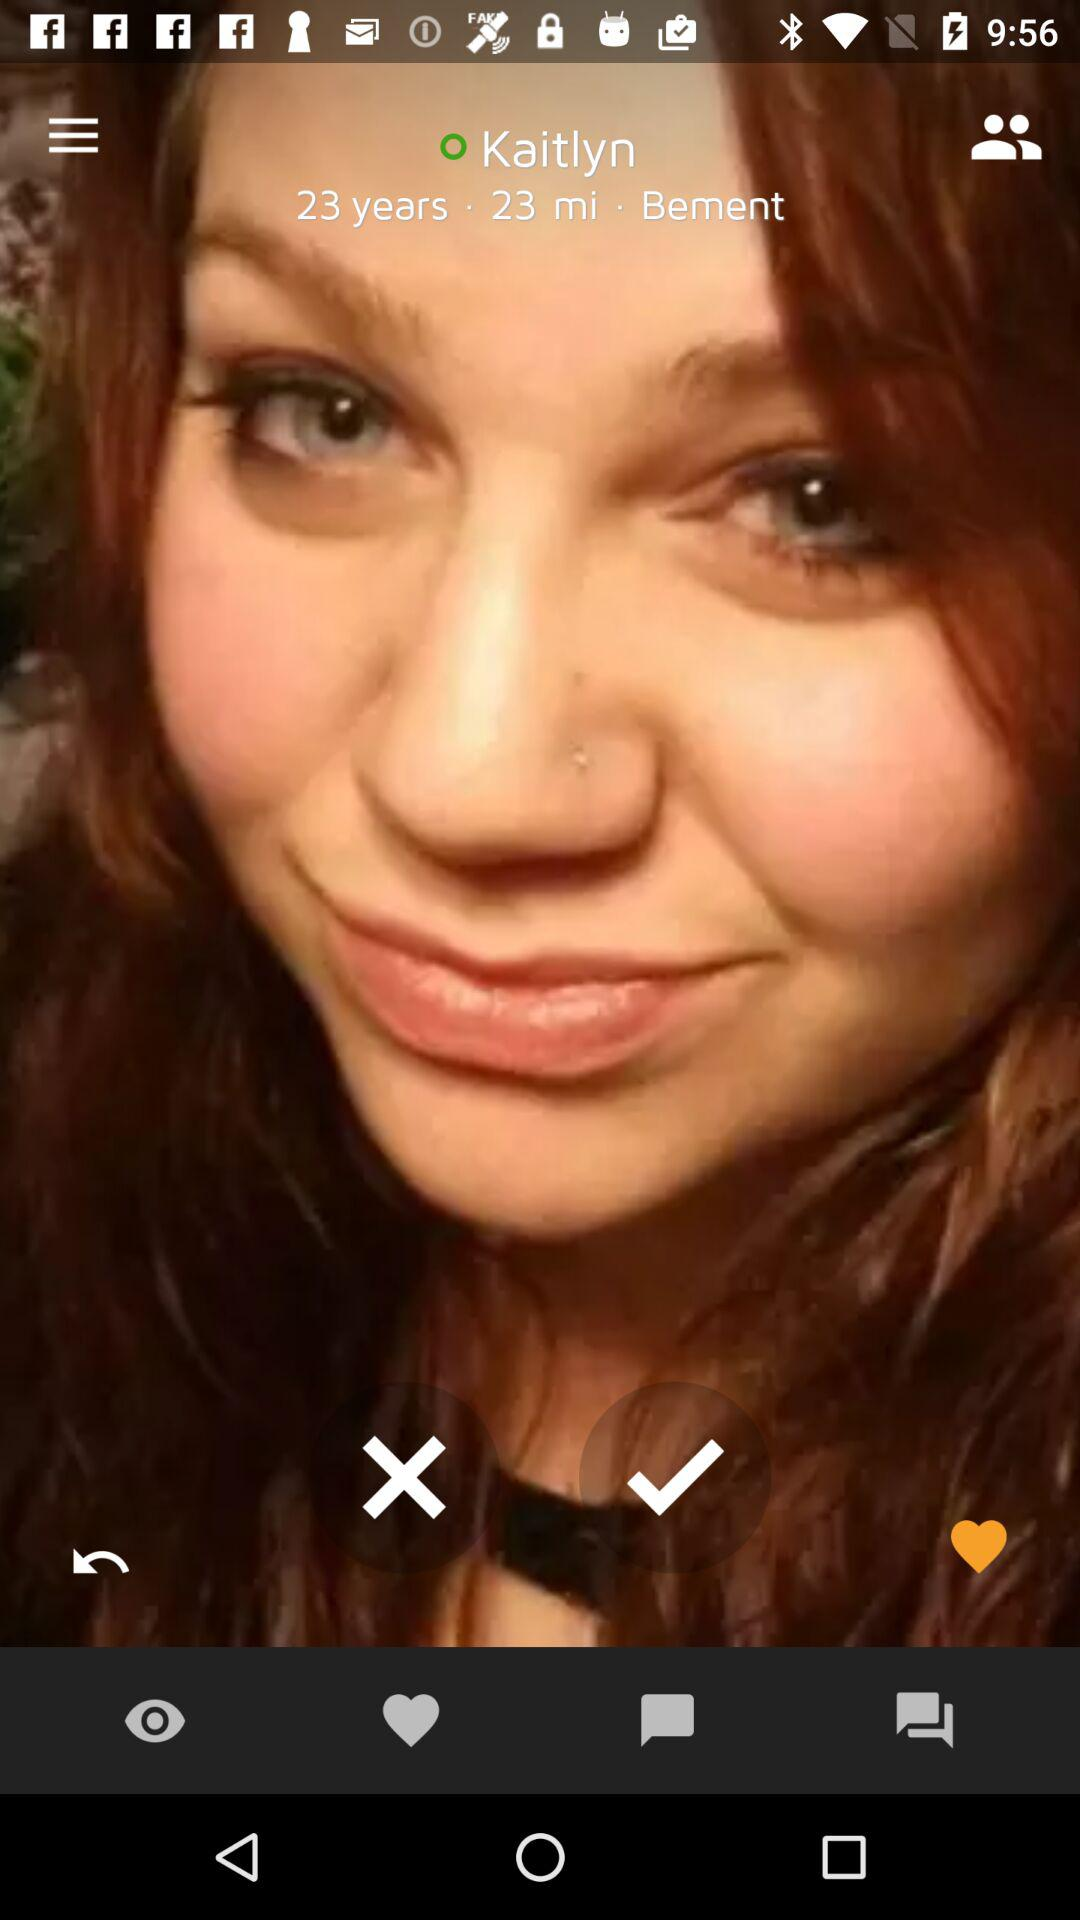What is the name of the mentioned place? The name of the mentioned place is Bement. 